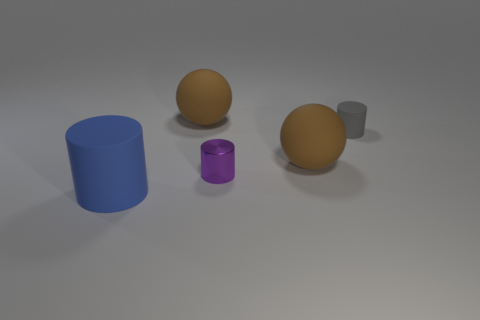What color is the shiny cylinder that is on the left side of the matte cylinder to the right of the blue matte thing?
Keep it short and to the point. Purple. There is another shiny thing that is the same shape as the gray object; what color is it?
Keep it short and to the point. Purple. Is there any other thing that has the same material as the tiny purple cylinder?
Offer a very short reply. No. There is a gray matte object that is the same shape as the metallic object; what size is it?
Ensure brevity in your answer.  Small. There is a big ball right of the metal thing; what material is it?
Keep it short and to the point. Rubber. Is the number of large blue matte cylinders that are right of the gray thing less than the number of big brown spheres?
Ensure brevity in your answer.  Yes. There is a tiny object that is left of the rubber cylinder that is to the right of the blue object; what shape is it?
Make the answer very short. Cylinder. What color is the small metal cylinder?
Your response must be concise. Purple. What number of other objects are the same size as the metal object?
Provide a short and direct response. 1. What material is the big object that is both to the right of the large blue matte thing and in front of the small gray matte cylinder?
Keep it short and to the point. Rubber. 